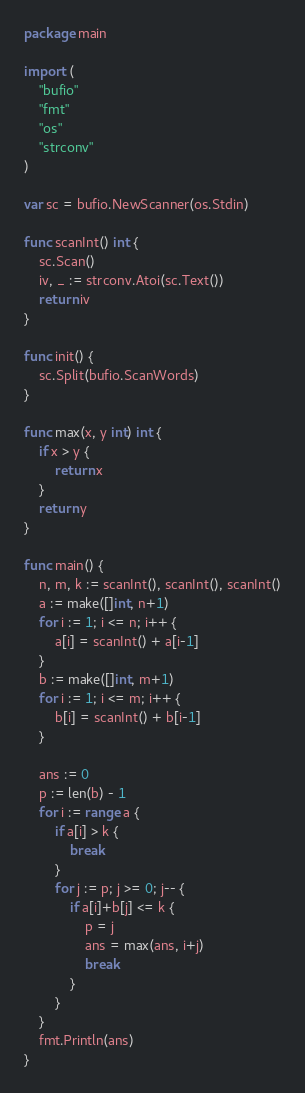Convert code to text. <code><loc_0><loc_0><loc_500><loc_500><_Go_>package main

import (
	"bufio"
	"fmt"
	"os"
	"strconv"
)

var sc = bufio.NewScanner(os.Stdin)

func scanInt() int {
	sc.Scan()
	iv, _ := strconv.Atoi(sc.Text())
	return iv
}

func init() {
	sc.Split(bufio.ScanWords)
}

func max(x, y int) int {
	if x > y {
		return x
	}
	return y
}

func main() {
	n, m, k := scanInt(), scanInt(), scanInt()
	a := make([]int, n+1)
	for i := 1; i <= n; i++ {
		a[i] = scanInt() + a[i-1]
	}
	b := make([]int, m+1)
	for i := 1; i <= m; i++ {
		b[i] = scanInt() + b[i-1]
	}

	ans := 0
	p := len(b) - 1
	for i := range a {
		if a[i] > k {
			break
		}
		for j := p; j >= 0; j-- {
			if a[i]+b[j] <= k {
				p = j
				ans = max(ans, i+j)
				break
			}
		}
	}
	fmt.Println(ans)
}
</code> 